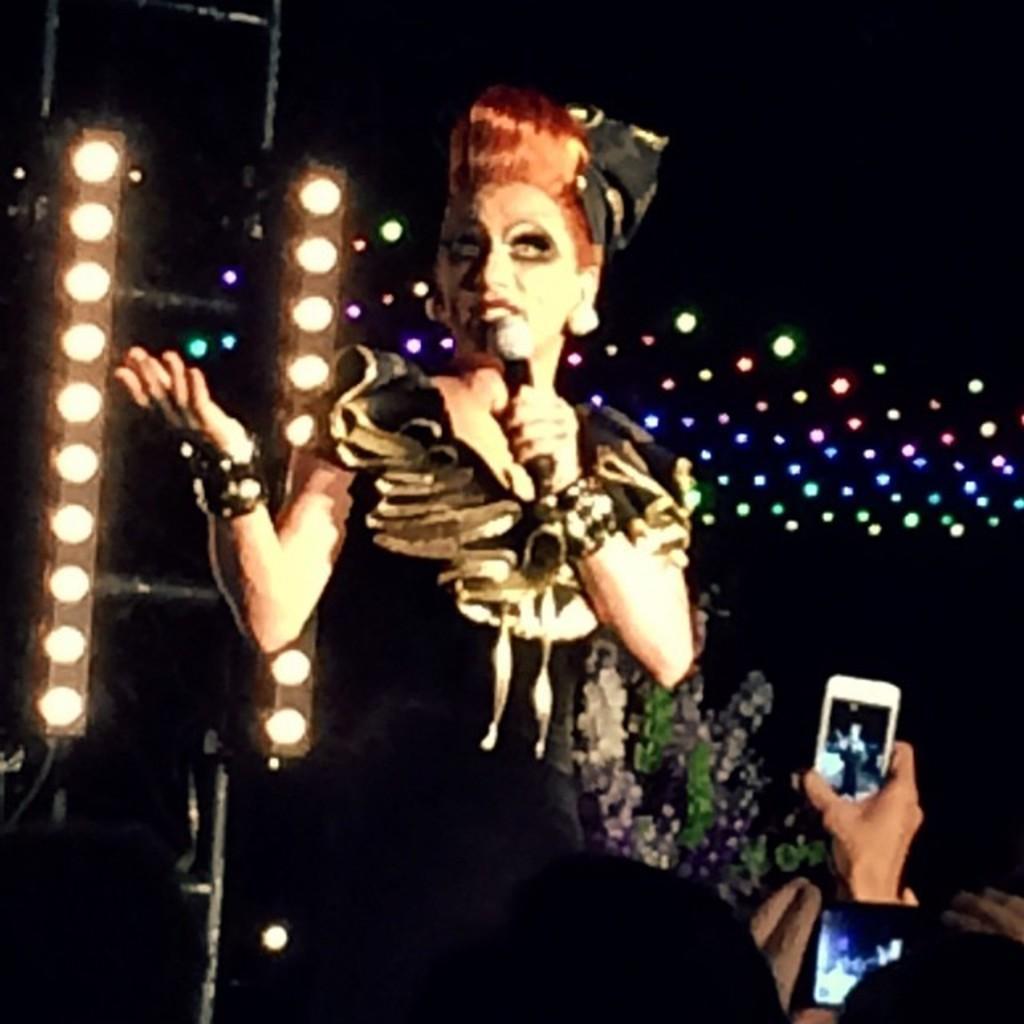Can you describe this image briefly? In this picture I can see a woman standing in front and I see that she is holding a mic. On the bottom right of this picture, I can see persons holding electronic devices. In the background I can see the lights and I see that it is a bit dark. 